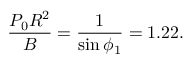Convert formula to latex. <formula><loc_0><loc_0><loc_500><loc_500>\frac { P _ { 0 } R ^ { 2 } } { B } = \frac { 1 } { \sin \phi _ { 1 } } = 1 . 2 2 .</formula> 